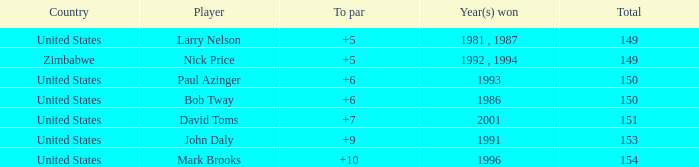How many to pars were won in 1993? 1.0. 